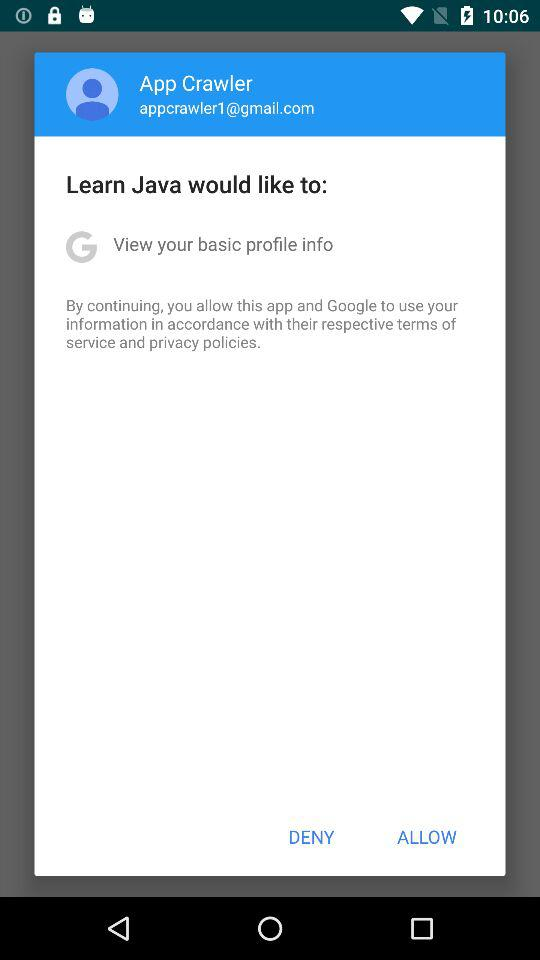What is the given profile name? The given profile name is App Crawler. 